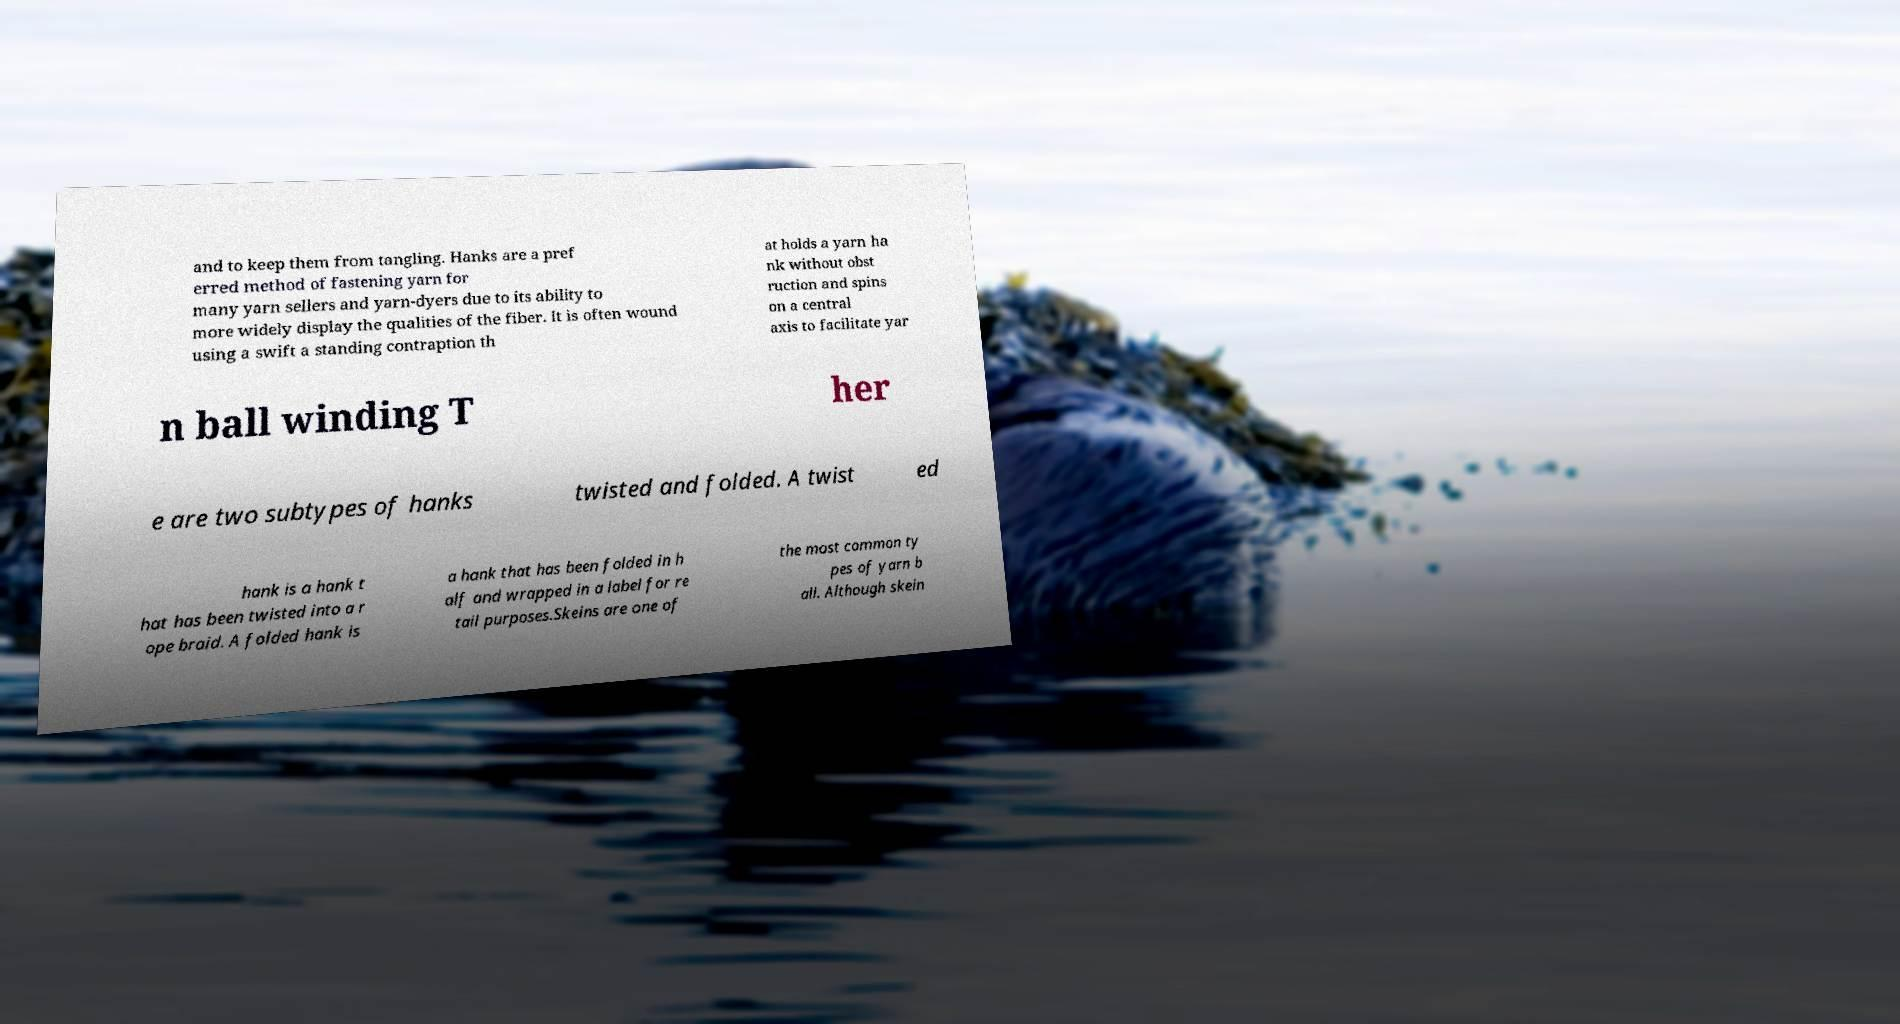Please identify and transcribe the text found in this image. and to keep them from tangling. Hanks are a pref erred method of fastening yarn for many yarn sellers and yarn-dyers due to its ability to more widely display the qualities of the fiber. It is often wound using a swift a standing contraption th at holds a yarn ha nk without obst ruction and spins on a central axis to facilitate yar n ball winding T her e are two subtypes of hanks twisted and folded. A twist ed hank is a hank t hat has been twisted into a r ope braid. A folded hank is a hank that has been folded in h alf and wrapped in a label for re tail purposes.Skeins are one of the most common ty pes of yarn b all. Although skein 